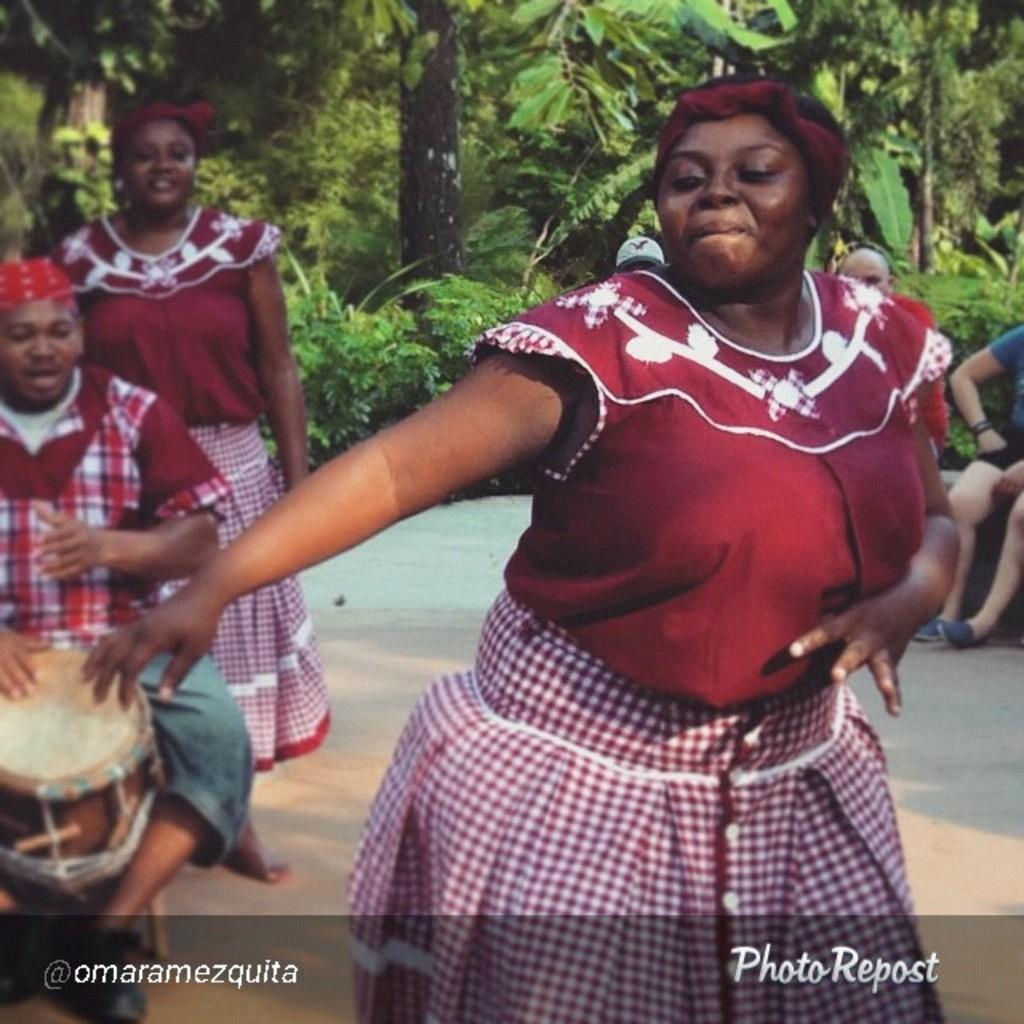What are the women in the image doing? The women are dancing in the image. Where are the women dancing? The women are dancing on a road. What can be seen in the background of the image? There are people sitting and a tree visible in the background of the image. What type of bone can be seen in the image? There is no bone present in the image. What is the taste of the shirt worn by one of the women in the image? The image does not provide information about the taste of any clothing, as it focuses on the women dancing and their surroundings. 